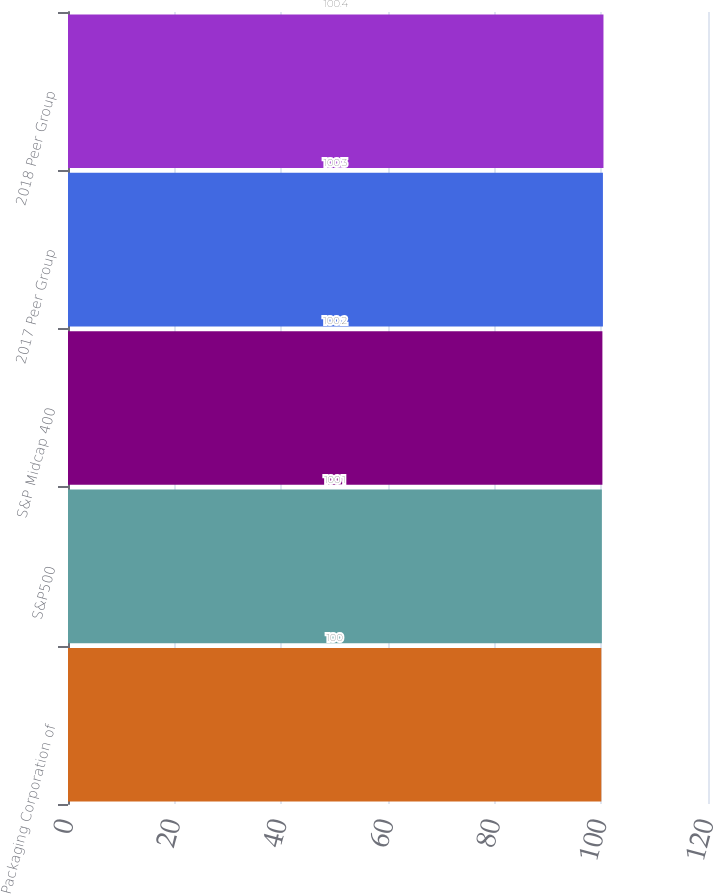Convert chart to OTSL. <chart><loc_0><loc_0><loc_500><loc_500><bar_chart><fcel>Packaging Corporation of<fcel>S&P500<fcel>S&P Midcap 400<fcel>2017 Peer Group<fcel>2018 Peer Group<nl><fcel>100<fcel>100.1<fcel>100.2<fcel>100.3<fcel>100.4<nl></chart> 